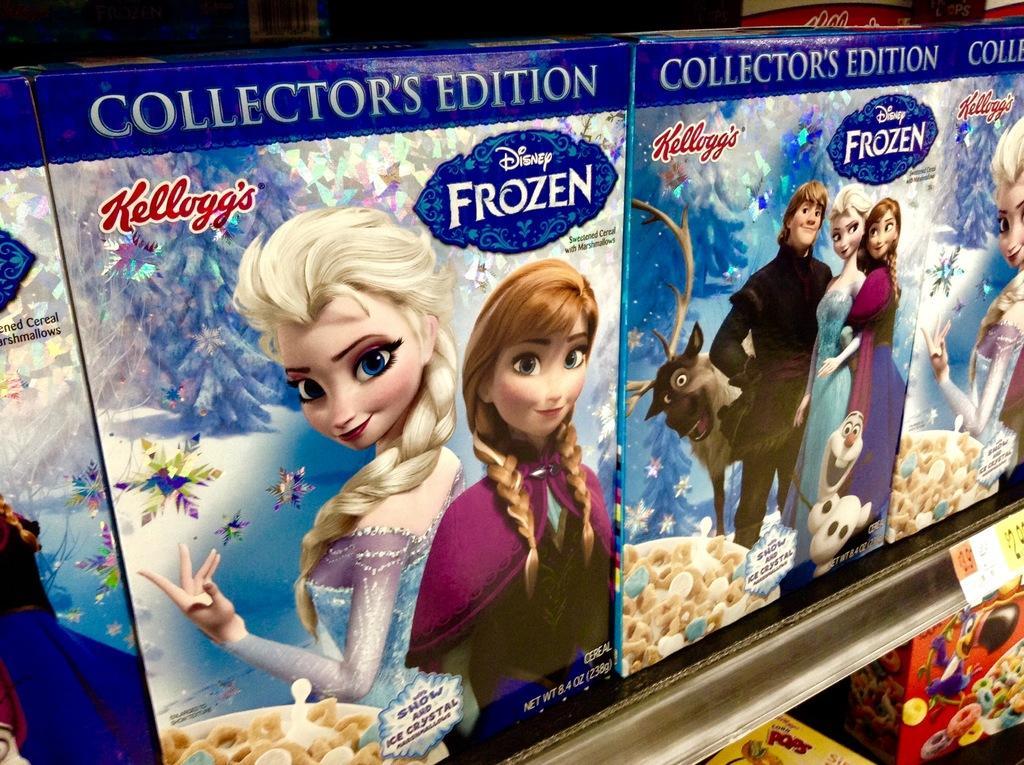How would you summarize this image in a sentence or two? In the image there are snacks boxes in the shelves and there is a price tag in front of the shelf. 